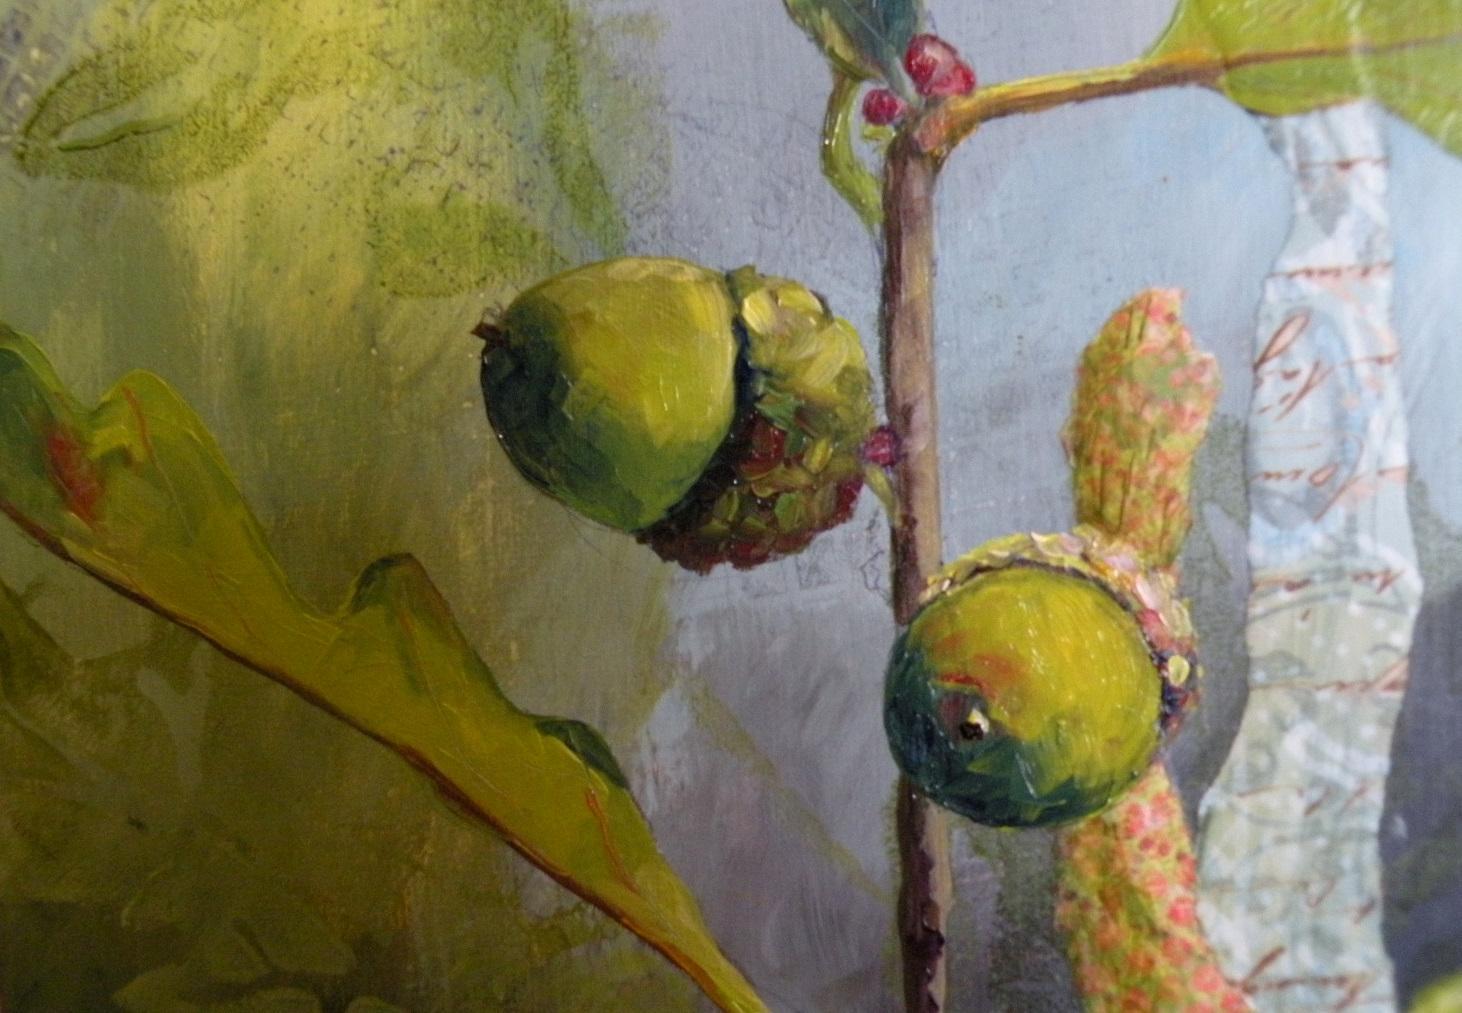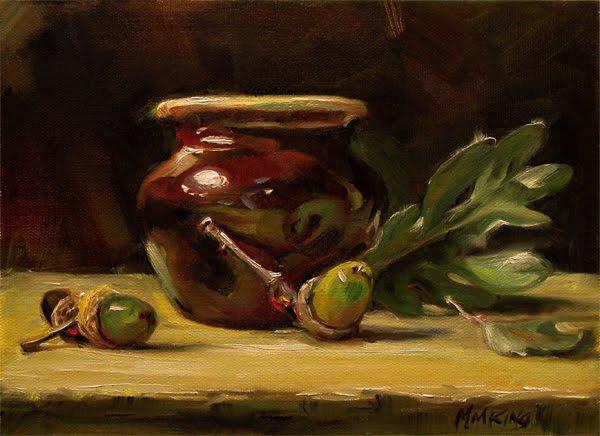The first image is the image on the left, the second image is the image on the right. Considering the images on both sides, is "There is only a single acorn it at least one of the images." valid? Answer yes or no. No. The first image is the image on the left, the second image is the image on the right. For the images displayed, is the sentence "Acorns are hanging on the limb yet to fall." factually correct? Answer yes or no. Yes. 